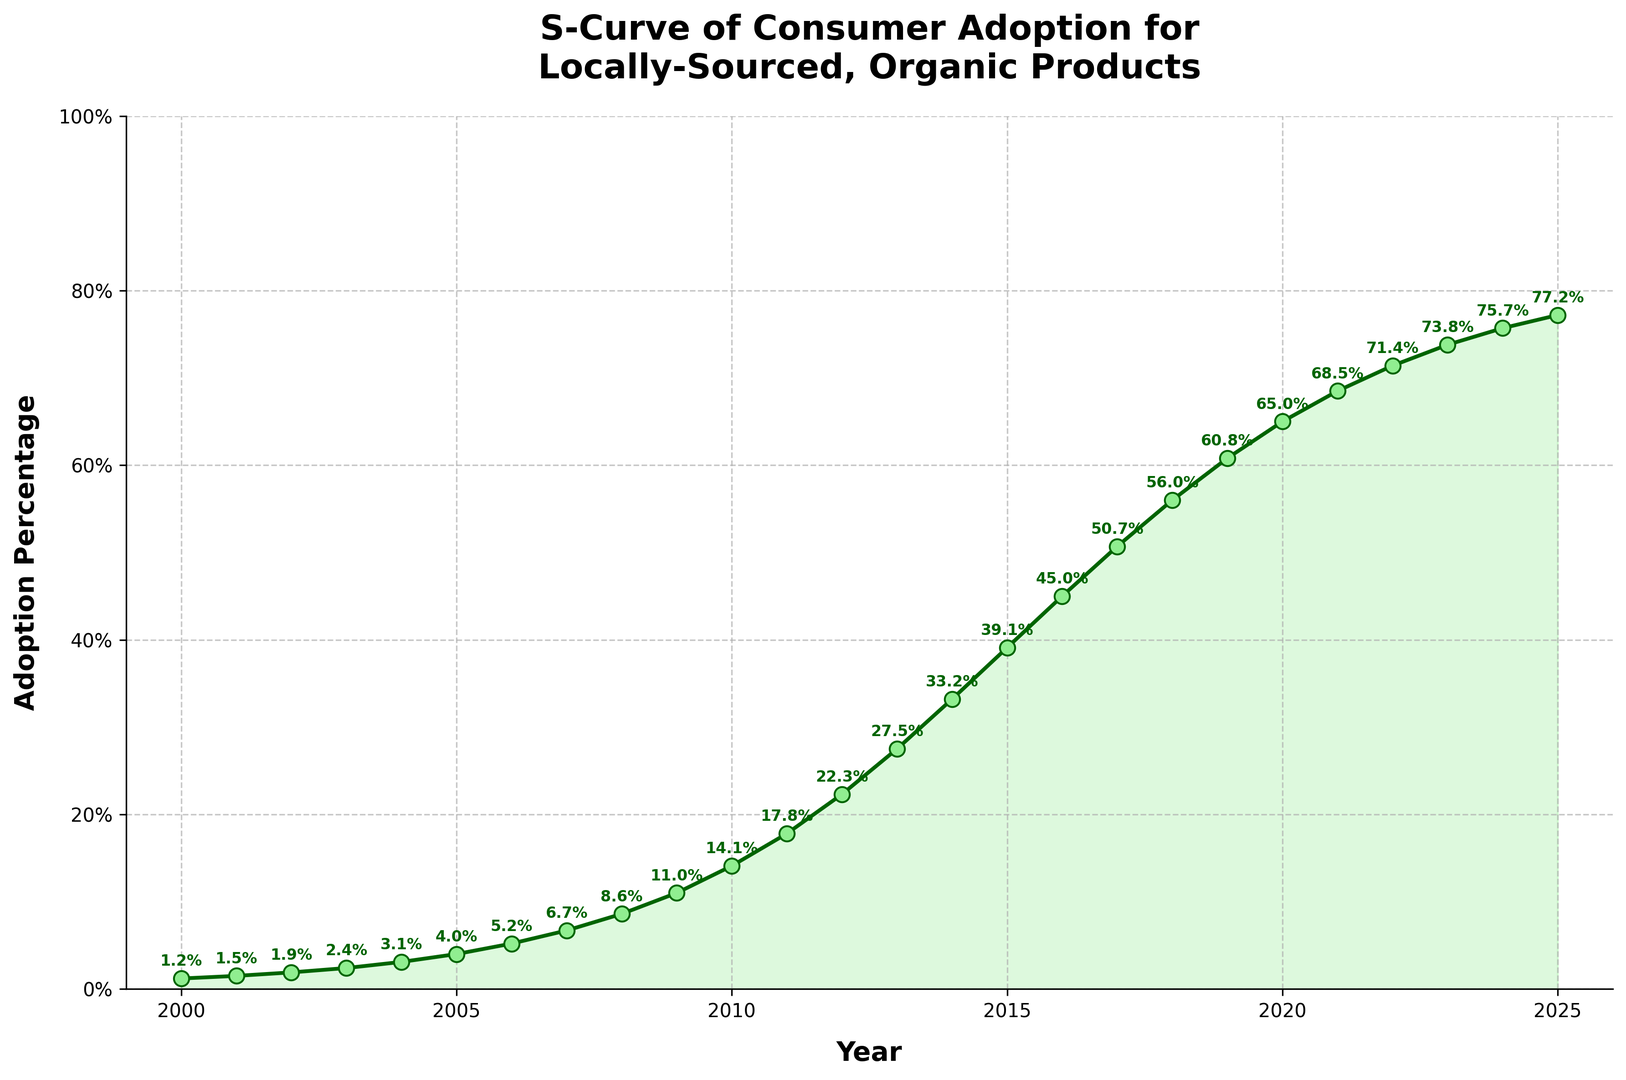What is the adoption percentage in 2020? The point on the plot for the year 2020 indicates the adoption percentage. Look for the value labeled on the plot for that year.
Answer: 65.0% In which year did the adoption percentage exceed 50%? The plot or the values shown indicate when the adoption percentage surpassed 50%. Check the values for each year.
Answer: 2017 Calculate the average adoption percentage from 2010 to 2015. Sum the adoption percentages for the years 2010 to 2015 and divide by the number of years (6). (14.1 + 17.8 + 22.3 + 27.5 + 33.2 + 39.1) / 6 = 154.0 / 6
Answer: 25.67% How many years did it take for the adoption percentage to reach 10%? Identify the first year in which the adoption percentage reaches or exceeds 10%. Subtract the initial year (2000) from this year. The year 2009 is the first time the adoption exceeds 10% (11.0%). 2009 - 2000 = 9 years.
Answer: 9 years Between which consecutive years is the largest increase in adoption percentage observed? Check the difference in adoption percentages between consecutive years and find the years with the largest difference. The largest increase is from 2012 (22.3%) to 2013 (27.5%). 27.5 - 22.3 = 5.2%.
Answer: 2012 to 2013 What is the color of the line representing the adoption percentage? Refer to the color of the line plotted for adoption percentage. It is a dark green line.
Answer: dark green How does the adoption percentage growth rate change before and after 2015? Analyze the slopes or differences before and after the year 2015. The growth rate is gradual before 2015 and increases significantly after that until 2018, then slows down a little but continues to rise.
Answer: Increases, then slows down after 2018 What year represents the midpoint (median) of the time range and what is the adoption percentage in that year? The midpoint in the time span 2000-2025 is (2000+2025)/2 = 2012.5, so consider the adoption percentage for 2012. In 2012, the adoption percentage is 22.3%.
Answer: 2012.5, 22.3% What pattern is noticeable in the visual representation of the adoption percentage over the years? The plot reveals an S-curve pattern with slow initial growth, followed by rapid increase, and then tapering off, typical of consumer adoption curves.
Answer: S-curve pattern 